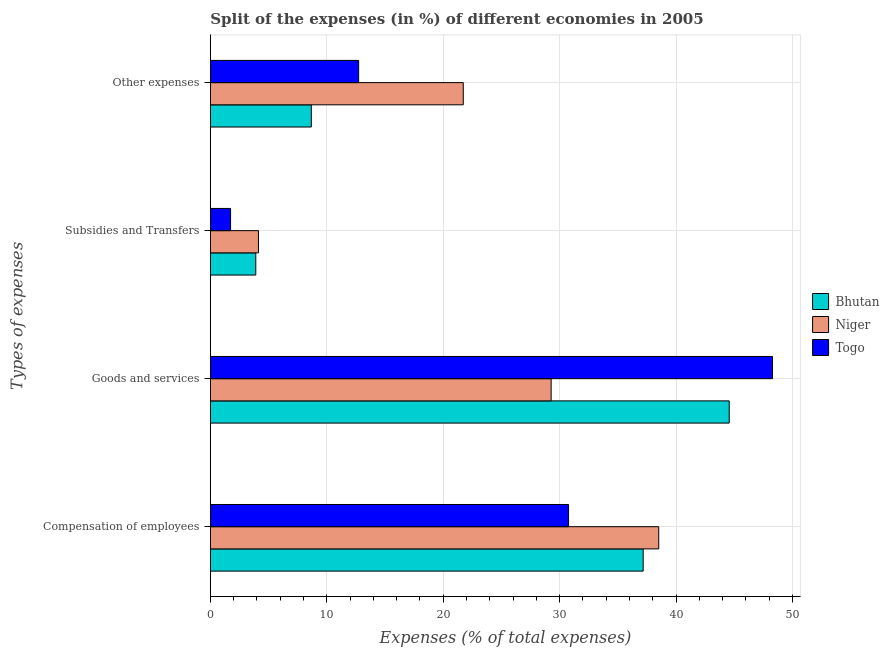How many groups of bars are there?
Your answer should be compact. 4. Are the number of bars on each tick of the Y-axis equal?
Your answer should be very brief. Yes. How many bars are there on the 2nd tick from the top?
Keep it short and to the point. 3. How many bars are there on the 2nd tick from the bottom?
Give a very brief answer. 3. What is the label of the 3rd group of bars from the top?
Ensure brevity in your answer.  Goods and services. What is the percentage of amount spent on goods and services in Togo?
Offer a very short reply. 48.29. Across all countries, what is the maximum percentage of amount spent on other expenses?
Give a very brief answer. 21.72. Across all countries, what is the minimum percentage of amount spent on compensation of employees?
Offer a terse response. 30.77. In which country was the percentage of amount spent on other expenses maximum?
Ensure brevity in your answer.  Niger. In which country was the percentage of amount spent on goods and services minimum?
Your response must be concise. Niger. What is the total percentage of amount spent on goods and services in the graph?
Your response must be concise. 122.13. What is the difference between the percentage of amount spent on goods and services in Niger and that in Togo?
Give a very brief answer. -19.01. What is the difference between the percentage of amount spent on goods and services in Niger and the percentage of amount spent on compensation of employees in Togo?
Ensure brevity in your answer.  -1.5. What is the average percentage of amount spent on compensation of employees per country?
Make the answer very short. 35.49. What is the difference between the percentage of amount spent on other expenses and percentage of amount spent on subsidies in Togo?
Make the answer very short. 11. What is the ratio of the percentage of amount spent on goods and services in Togo to that in Bhutan?
Give a very brief answer. 1.08. What is the difference between the highest and the second highest percentage of amount spent on other expenses?
Your response must be concise. 8.99. What is the difference between the highest and the lowest percentage of amount spent on goods and services?
Ensure brevity in your answer.  19.01. Is it the case that in every country, the sum of the percentage of amount spent on compensation of employees and percentage of amount spent on goods and services is greater than the sum of percentage of amount spent on subsidies and percentage of amount spent on other expenses?
Offer a very short reply. Yes. What does the 2nd bar from the top in Goods and services represents?
Your answer should be very brief. Niger. What does the 2nd bar from the bottom in Goods and services represents?
Keep it short and to the point. Niger. Is it the case that in every country, the sum of the percentage of amount spent on compensation of employees and percentage of amount spent on goods and services is greater than the percentage of amount spent on subsidies?
Ensure brevity in your answer.  Yes. Are all the bars in the graph horizontal?
Offer a very short reply. Yes. What is the difference between two consecutive major ticks on the X-axis?
Keep it short and to the point. 10. Are the values on the major ticks of X-axis written in scientific E-notation?
Offer a very short reply. No. Does the graph contain any zero values?
Offer a terse response. No. Does the graph contain grids?
Your answer should be compact. Yes. Where does the legend appear in the graph?
Make the answer very short. Center right. How many legend labels are there?
Give a very brief answer. 3. What is the title of the graph?
Your answer should be compact. Split of the expenses (in %) of different economies in 2005. Does "Korea (Democratic)" appear as one of the legend labels in the graph?
Offer a terse response. No. What is the label or title of the X-axis?
Offer a terse response. Expenses (% of total expenses). What is the label or title of the Y-axis?
Keep it short and to the point. Types of expenses. What is the Expenses (% of total expenses) of Bhutan in Compensation of employees?
Your answer should be very brief. 37.18. What is the Expenses (% of total expenses) of Niger in Compensation of employees?
Your response must be concise. 38.51. What is the Expenses (% of total expenses) of Togo in Compensation of employees?
Make the answer very short. 30.77. What is the Expenses (% of total expenses) of Bhutan in Goods and services?
Your response must be concise. 44.57. What is the Expenses (% of total expenses) in Niger in Goods and services?
Your response must be concise. 29.27. What is the Expenses (% of total expenses) in Togo in Goods and services?
Make the answer very short. 48.29. What is the Expenses (% of total expenses) in Bhutan in Subsidies and Transfers?
Ensure brevity in your answer.  3.9. What is the Expenses (% of total expenses) in Niger in Subsidies and Transfers?
Your response must be concise. 4.13. What is the Expenses (% of total expenses) of Togo in Subsidies and Transfers?
Make the answer very short. 1.74. What is the Expenses (% of total expenses) in Bhutan in Other expenses?
Offer a terse response. 8.67. What is the Expenses (% of total expenses) in Niger in Other expenses?
Provide a short and direct response. 21.72. What is the Expenses (% of total expenses) of Togo in Other expenses?
Your response must be concise. 12.74. Across all Types of expenses, what is the maximum Expenses (% of total expenses) in Bhutan?
Give a very brief answer. 44.57. Across all Types of expenses, what is the maximum Expenses (% of total expenses) in Niger?
Give a very brief answer. 38.51. Across all Types of expenses, what is the maximum Expenses (% of total expenses) of Togo?
Your answer should be very brief. 48.29. Across all Types of expenses, what is the minimum Expenses (% of total expenses) in Bhutan?
Ensure brevity in your answer.  3.9. Across all Types of expenses, what is the minimum Expenses (% of total expenses) of Niger?
Offer a very short reply. 4.13. Across all Types of expenses, what is the minimum Expenses (% of total expenses) of Togo?
Keep it short and to the point. 1.74. What is the total Expenses (% of total expenses) in Bhutan in the graph?
Offer a terse response. 94.32. What is the total Expenses (% of total expenses) of Niger in the graph?
Give a very brief answer. 93.64. What is the total Expenses (% of total expenses) in Togo in the graph?
Offer a terse response. 93.53. What is the difference between the Expenses (% of total expenses) of Bhutan in Compensation of employees and that in Goods and services?
Offer a very short reply. -7.39. What is the difference between the Expenses (% of total expenses) of Niger in Compensation of employees and that in Goods and services?
Offer a terse response. 9.24. What is the difference between the Expenses (% of total expenses) of Togo in Compensation of employees and that in Goods and services?
Your answer should be compact. -17.52. What is the difference between the Expenses (% of total expenses) in Bhutan in Compensation of employees and that in Subsidies and Transfers?
Provide a succinct answer. 33.28. What is the difference between the Expenses (% of total expenses) of Niger in Compensation of employees and that in Subsidies and Transfers?
Give a very brief answer. 34.38. What is the difference between the Expenses (% of total expenses) in Togo in Compensation of employees and that in Subsidies and Transfers?
Your answer should be very brief. 29.03. What is the difference between the Expenses (% of total expenses) in Bhutan in Compensation of employees and that in Other expenses?
Your answer should be compact. 28.51. What is the difference between the Expenses (% of total expenses) in Niger in Compensation of employees and that in Other expenses?
Make the answer very short. 16.79. What is the difference between the Expenses (% of total expenses) in Togo in Compensation of employees and that in Other expenses?
Offer a terse response. 18.03. What is the difference between the Expenses (% of total expenses) in Bhutan in Goods and services and that in Subsidies and Transfers?
Ensure brevity in your answer.  40.67. What is the difference between the Expenses (% of total expenses) of Niger in Goods and services and that in Subsidies and Transfers?
Offer a terse response. 25.14. What is the difference between the Expenses (% of total expenses) in Togo in Goods and services and that in Subsidies and Transfers?
Make the answer very short. 46.55. What is the difference between the Expenses (% of total expenses) in Bhutan in Goods and services and that in Other expenses?
Your response must be concise. 35.9. What is the difference between the Expenses (% of total expenses) of Niger in Goods and services and that in Other expenses?
Keep it short and to the point. 7.55. What is the difference between the Expenses (% of total expenses) in Togo in Goods and services and that in Other expenses?
Offer a very short reply. 35.55. What is the difference between the Expenses (% of total expenses) in Bhutan in Subsidies and Transfers and that in Other expenses?
Ensure brevity in your answer.  -4.77. What is the difference between the Expenses (% of total expenses) of Niger in Subsidies and Transfers and that in Other expenses?
Offer a very short reply. -17.59. What is the difference between the Expenses (% of total expenses) in Togo in Subsidies and Transfers and that in Other expenses?
Give a very brief answer. -11. What is the difference between the Expenses (% of total expenses) in Bhutan in Compensation of employees and the Expenses (% of total expenses) in Niger in Goods and services?
Provide a short and direct response. 7.91. What is the difference between the Expenses (% of total expenses) in Bhutan in Compensation of employees and the Expenses (% of total expenses) in Togo in Goods and services?
Provide a succinct answer. -11.11. What is the difference between the Expenses (% of total expenses) of Niger in Compensation of employees and the Expenses (% of total expenses) of Togo in Goods and services?
Offer a very short reply. -9.77. What is the difference between the Expenses (% of total expenses) of Bhutan in Compensation of employees and the Expenses (% of total expenses) of Niger in Subsidies and Transfers?
Provide a succinct answer. 33.05. What is the difference between the Expenses (% of total expenses) of Bhutan in Compensation of employees and the Expenses (% of total expenses) of Togo in Subsidies and Transfers?
Keep it short and to the point. 35.44. What is the difference between the Expenses (% of total expenses) of Niger in Compensation of employees and the Expenses (% of total expenses) of Togo in Subsidies and Transfers?
Make the answer very short. 36.78. What is the difference between the Expenses (% of total expenses) of Bhutan in Compensation of employees and the Expenses (% of total expenses) of Niger in Other expenses?
Provide a short and direct response. 15.45. What is the difference between the Expenses (% of total expenses) of Bhutan in Compensation of employees and the Expenses (% of total expenses) of Togo in Other expenses?
Your response must be concise. 24.44. What is the difference between the Expenses (% of total expenses) of Niger in Compensation of employees and the Expenses (% of total expenses) of Togo in Other expenses?
Make the answer very short. 25.78. What is the difference between the Expenses (% of total expenses) in Bhutan in Goods and services and the Expenses (% of total expenses) in Niger in Subsidies and Transfers?
Give a very brief answer. 40.44. What is the difference between the Expenses (% of total expenses) of Bhutan in Goods and services and the Expenses (% of total expenses) of Togo in Subsidies and Transfers?
Ensure brevity in your answer.  42.83. What is the difference between the Expenses (% of total expenses) of Niger in Goods and services and the Expenses (% of total expenses) of Togo in Subsidies and Transfers?
Your answer should be compact. 27.54. What is the difference between the Expenses (% of total expenses) of Bhutan in Goods and services and the Expenses (% of total expenses) of Niger in Other expenses?
Offer a terse response. 22.85. What is the difference between the Expenses (% of total expenses) in Bhutan in Goods and services and the Expenses (% of total expenses) in Togo in Other expenses?
Offer a terse response. 31.83. What is the difference between the Expenses (% of total expenses) in Niger in Goods and services and the Expenses (% of total expenses) in Togo in Other expenses?
Your answer should be compact. 16.54. What is the difference between the Expenses (% of total expenses) of Bhutan in Subsidies and Transfers and the Expenses (% of total expenses) of Niger in Other expenses?
Your answer should be very brief. -17.82. What is the difference between the Expenses (% of total expenses) of Bhutan in Subsidies and Transfers and the Expenses (% of total expenses) of Togo in Other expenses?
Give a very brief answer. -8.84. What is the difference between the Expenses (% of total expenses) of Niger in Subsidies and Transfers and the Expenses (% of total expenses) of Togo in Other expenses?
Ensure brevity in your answer.  -8.61. What is the average Expenses (% of total expenses) of Bhutan per Types of expenses?
Your answer should be compact. 23.58. What is the average Expenses (% of total expenses) in Niger per Types of expenses?
Offer a terse response. 23.41. What is the average Expenses (% of total expenses) of Togo per Types of expenses?
Keep it short and to the point. 23.38. What is the difference between the Expenses (% of total expenses) of Bhutan and Expenses (% of total expenses) of Niger in Compensation of employees?
Ensure brevity in your answer.  -1.34. What is the difference between the Expenses (% of total expenses) in Bhutan and Expenses (% of total expenses) in Togo in Compensation of employees?
Keep it short and to the point. 6.41. What is the difference between the Expenses (% of total expenses) in Niger and Expenses (% of total expenses) in Togo in Compensation of employees?
Give a very brief answer. 7.75. What is the difference between the Expenses (% of total expenses) of Bhutan and Expenses (% of total expenses) of Niger in Goods and services?
Make the answer very short. 15.3. What is the difference between the Expenses (% of total expenses) of Bhutan and Expenses (% of total expenses) of Togo in Goods and services?
Ensure brevity in your answer.  -3.72. What is the difference between the Expenses (% of total expenses) in Niger and Expenses (% of total expenses) in Togo in Goods and services?
Your answer should be very brief. -19.01. What is the difference between the Expenses (% of total expenses) of Bhutan and Expenses (% of total expenses) of Niger in Subsidies and Transfers?
Offer a terse response. -0.23. What is the difference between the Expenses (% of total expenses) in Bhutan and Expenses (% of total expenses) in Togo in Subsidies and Transfers?
Ensure brevity in your answer.  2.17. What is the difference between the Expenses (% of total expenses) in Niger and Expenses (% of total expenses) in Togo in Subsidies and Transfers?
Offer a terse response. 2.39. What is the difference between the Expenses (% of total expenses) in Bhutan and Expenses (% of total expenses) in Niger in Other expenses?
Your answer should be compact. -13.05. What is the difference between the Expenses (% of total expenses) in Bhutan and Expenses (% of total expenses) in Togo in Other expenses?
Your answer should be compact. -4.07. What is the difference between the Expenses (% of total expenses) of Niger and Expenses (% of total expenses) of Togo in Other expenses?
Provide a short and direct response. 8.99. What is the ratio of the Expenses (% of total expenses) of Bhutan in Compensation of employees to that in Goods and services?
Offer a very short reply. 0.83. What is the ratio of the Expenses (% of total expenses) in Niger in Compensation of employees to that in Goods and services?
Keep it short and to the point. 1.32. What is the ratio of the Expenses (% of total expenses) in Togo in Compensation of employees to that in Goods and services?
Keep it short and to the point. 0.64. What is the ratio of the Expenses (% of total expenses) of Bhutan in Compensation of employees to that in Subsidies and Transfers?
Your response must be concise. 9.53. What is the ratio of the Expenses (% of total expenses) in Niger in Compensation of employees to that in Subsidies and Transfers?
Ensure brevity in your answer.  9.33. What is the ratio of the Expenses (% of total expenses) in Togo in Compensation of employees to that in Subsidies and Transfers?
Your response must be concise. 17.73. What is the ratio of the Expenses (% of total expenses) in Bhutan in Compensation of employees to that in Other expenses?
Your answer should be compact. 4.29. What is the ratio of the Expenses (% of total expenses) in Niger in Compensation of employees to that in Other expenses?
Keep it short and to the point. 1.77. What is the ratio of the Expenses (% of total expenses) in Togo in Compensation of employees to that in Other expenses?
Ensure brevity in your answer.  2.42. What is the ratio of the Expenses (% of total expenses) of Bhutan in Goods and services to that in Subsidies and Transfers?
Provide a short and direct response. 11.43. What is the ratio of the Expenses (% of total expenses) of Niger in Goods and services to that in Subsidies and Transfers?
Provide a short and direct response. 7.09. What is the ratio of the Expenses (% of total expenses) of Togo in Goods and services to that in Subsidies and Transfers?
Provide a succinct answer. 27.83. What is the ratio of the Expenses (% of total expenses) in Bhutan in Goods and services to that in Other expenses?
Give a very brief answer. 5.14. What is the ratio of the Expenses (% of total expenses) of Niger in Goods and services to that in Other expenses?
Offer a very short reply. 1.35. What is the ratio of the Expenses (% of total expenses) of Togo in Goods and services to that in Other expenses?
Your answer should be very brief. 3.79. What is the ratio of the Expenses (% of total expenses) of Bhutan in Subsidies and Transfers to that in Other expenses?
Your response must be concise. 0.45. What is the ratio of the Expenses (% of total expenses) in Niger in Subsidies and Transfers to that in Other expenses?
Make the answer very short. 0.19. What is the ratio of the Expenses (% of total expenses) in Togo in Subsidies and Transfers to that in Other expenses?
Your answer should be very brief. 0.14. What is the difference between the highest and the second highest Expenses (% of total expenses) in Bhutan?
Offer a very short reply. 7.39. What is the difference between the highest and the second highest Expenses (% of total expenses) of Niger?
Keep it short and to the point. 9.24. What is the difference between the highest and the second highest Expenses (% of total expenses) of Togo?
Give a very brief answer. 17.52. What is the difference between the highest and the lowest Expenses (% of total expenses) in Bhutan?
Provide a short and direct response. 40.67. What is the difference between the highest and the lowest Expenses (% of total expenses) in Niger?
Your answer should be compact. 34.38. What is the difference between the highest and the lowest Expenses (% of total expenses) of Togo?
Provide a succinct answer. 46.55. 